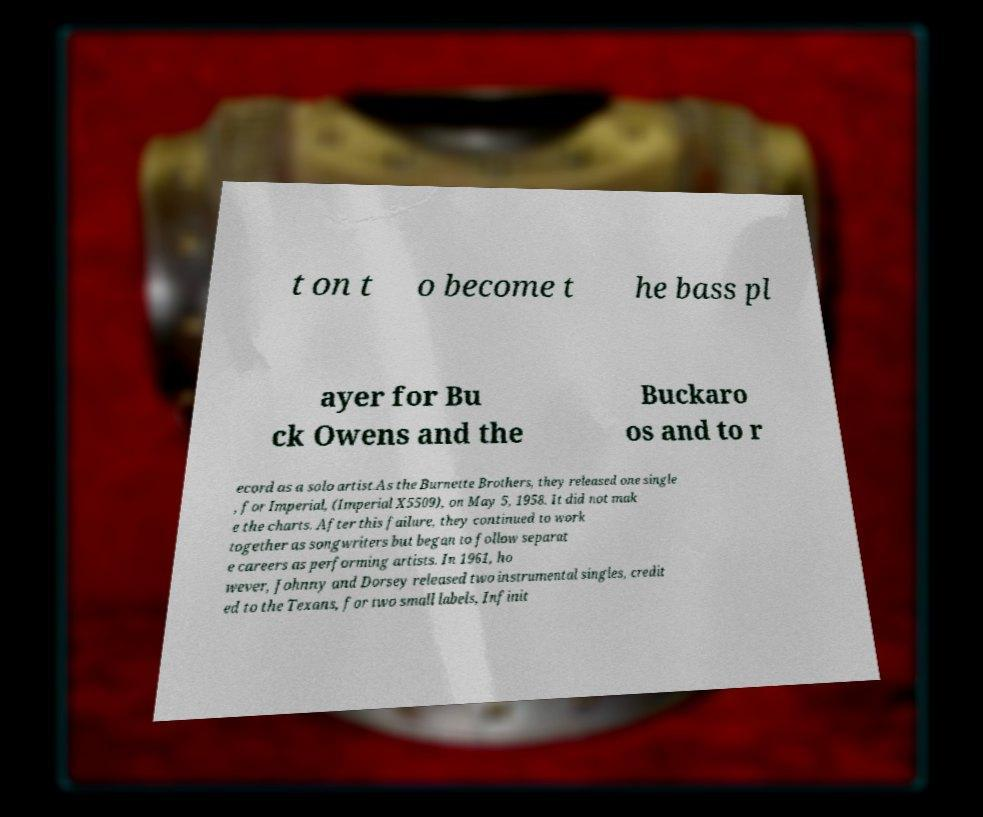Could you assist in decoding the text presented in this image and type it out clearly? t on t o become t he bass pl ayer for Bu ck Owens and the Buckaro os and to r ecord as a solo artist.As the Burnette Brothers, they released one single , for Imperial, (Imperial X5509), on May 5, 1958. It did not mak e the charts. After this failure, they continued to work together as songwriters but began to follow separat e careers as performing artists. In 1961, ho wever, Johnny and Dorsey released two instrumental singles, credit ed to the Texans, for two small labels, Infinit 